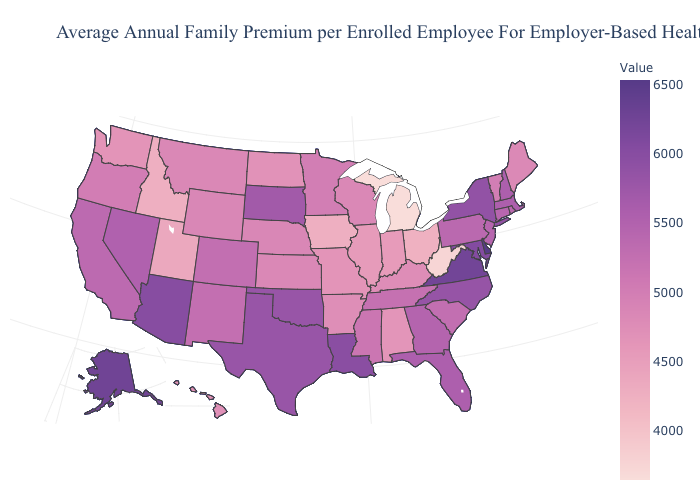Which states have the lowest value in the USA?
Concise answer only. Michigan. Does Nebraska have the lowest value in the MidWest?
Concise answer only. No. Is the legend a continuous bar?
Short answer required. Yes. Which states have the lowest value in the South?
Concise answer only. West Virginia. Is the legend a continuous bar?
Concise answer only. Yes. Does Iowa have the lowest value in the MidWest?
Give a very brief answer. No. 